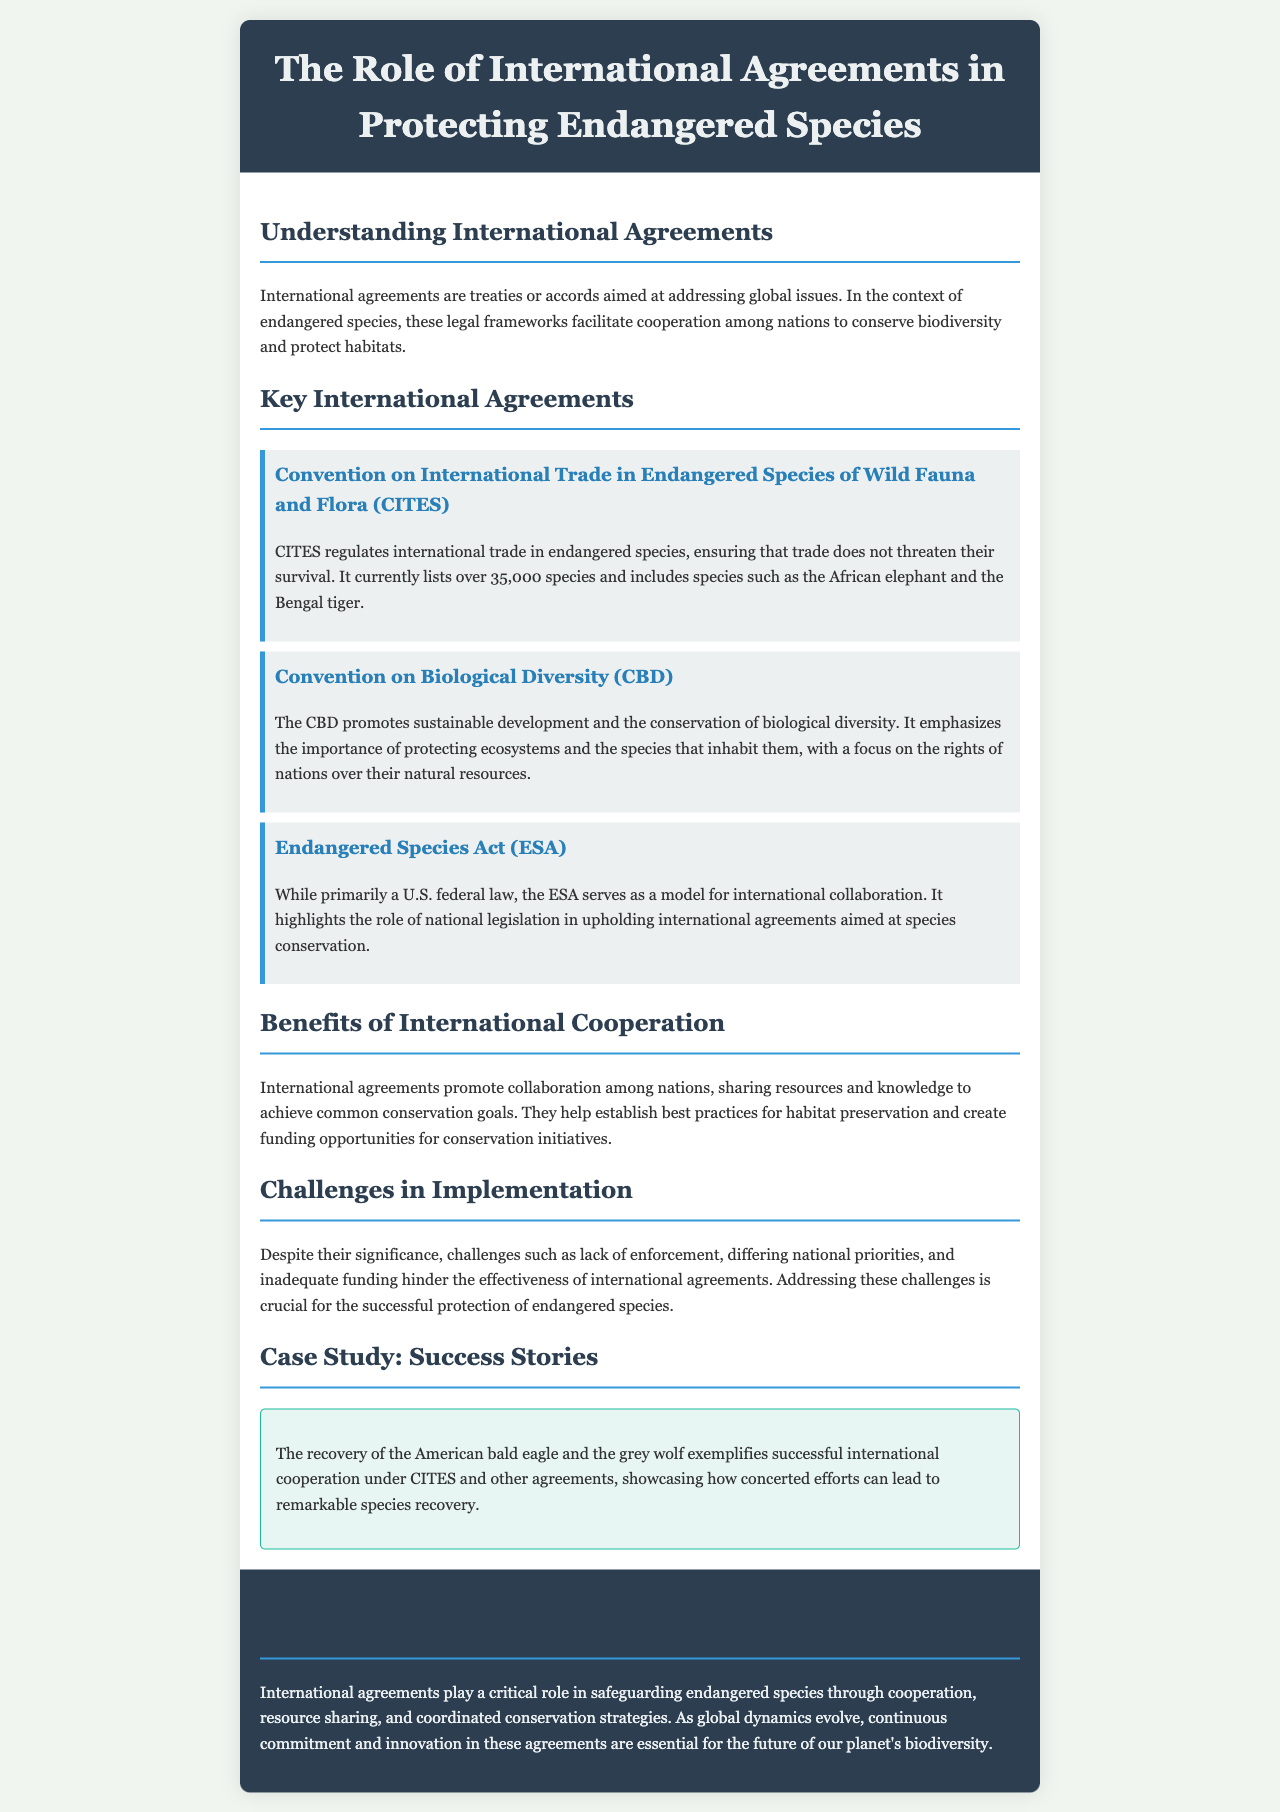What is CITES? CITES is the Convention on International Trade in Endangered Species of Wild Fauna and Flora, which regulates international trade in endangered species.
Answer: Convention on International Trade in Endangered Species of Wild Fauna and Flora How many species does CITES currently list? The document states that CITES currently lists over 35,000 species.
Answer: over 35,000 species What is the primary focus of the Convention on Biological Diversity? The CBD emphasizes the importance of protecting ecosystems and the species that inhabit them.
Answer: protecting ecosystems and species Which U.S. law serves as a model for international collaboration? The Endangered Species Act is mentioned as a model for international collaboration in species conservation.
Answer: Endangered Species Act What are the challenges in implementing international agreements? The document highlights lack of enforcement, differing national priorities, and inadequate funding as challenges.
Answer: lack of enforcement, differing national priorities, inadequate funding What are the benefits of international cooperation? International agreements promote sharing resources and knowledge to achieve common conservation goals.
Answer: sharing resources and knowledge Which two species exemplify successful international cooperation? The recovery of the American bald eagle and the grey wolf are given as examples of successful international cooperation.
Answer: American bald eagle and grey wolf What is the role of international agreements in protecting endangered species? International agreements play a critical role in safeguarding endangered species through cooperation and coordinated conservation strategies.
Answer: safeguarding endangered species through cooperation What is a significant feature of the brochure's design? The brochure features a clean layout with sections that are clearly defined by headings and background colors.
Answer: clean layout with sections clearly defined 